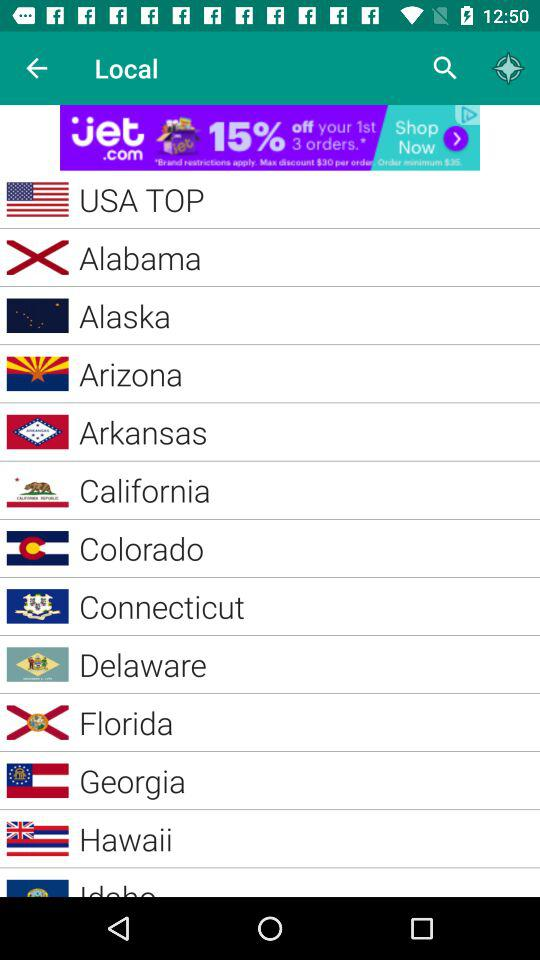What are the mentioned states? The mentioned states are Alabama, Alaska, Arizona, Arkansas, California, Colorado, Connecticut, Delaware, Florida, Georgia and Hawaii. 